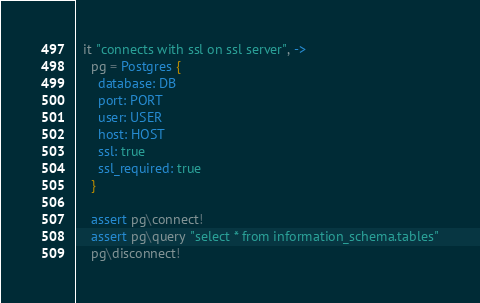<code> <loc_0><loc_0><loc_500><loc_500><_MoonScript_>  it "connects with ssl on ssl server", ->
    pg = Postgres {
      database: DB
      port: PORT
      user: USER
      host: HOST
      ssl: true
      ssl_required: true
    }

    assert pg\connect!
    assert pg\query "select * from information_schema.tables"
    pg\disconnect!



</code> 